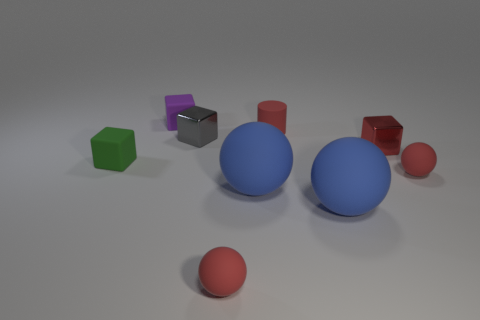What material is the block that is the same color as the tiny cylinder?
Provide a short and direct response. Metal. Are there fewer green matte cubes behind the cylinder than small red matte things that are on the left side of the small gray shiny cube?
Keep it short and to the point. No. Does the red cylinder have the same material as the purple object?
Your answer should be very brief. Yes. What size is the red thing that is in front of the small red shiny block and to the right of the cylinder?
Offer a very short reply. Small. There is a red metal thing that is the same size as the purple cube; what is its shape?
Provide a short and direct response. Cube. There is a red cylinder to the right of the small rubber object that is left of the block that is behind the gray metallic object; what is it made of?
Your answer should be very brief. Rubber. There is a blue thing on the left side of the small cylinder; is its shape the same as the red object that is behind the small gray metallic thing?
Ensure brevity in your answer.  No. How many other objects are the same material as the cylinder?
Your answer should be very brief. 6. Does the small cube behind the gray metal block have the same material as the small cube on the right side of the gray cube?
Give a very brief answer. No. There is a tiny green thing that is made of the same material as the purple cube; what is its shape?
Provide a short and direct response. Cube. 